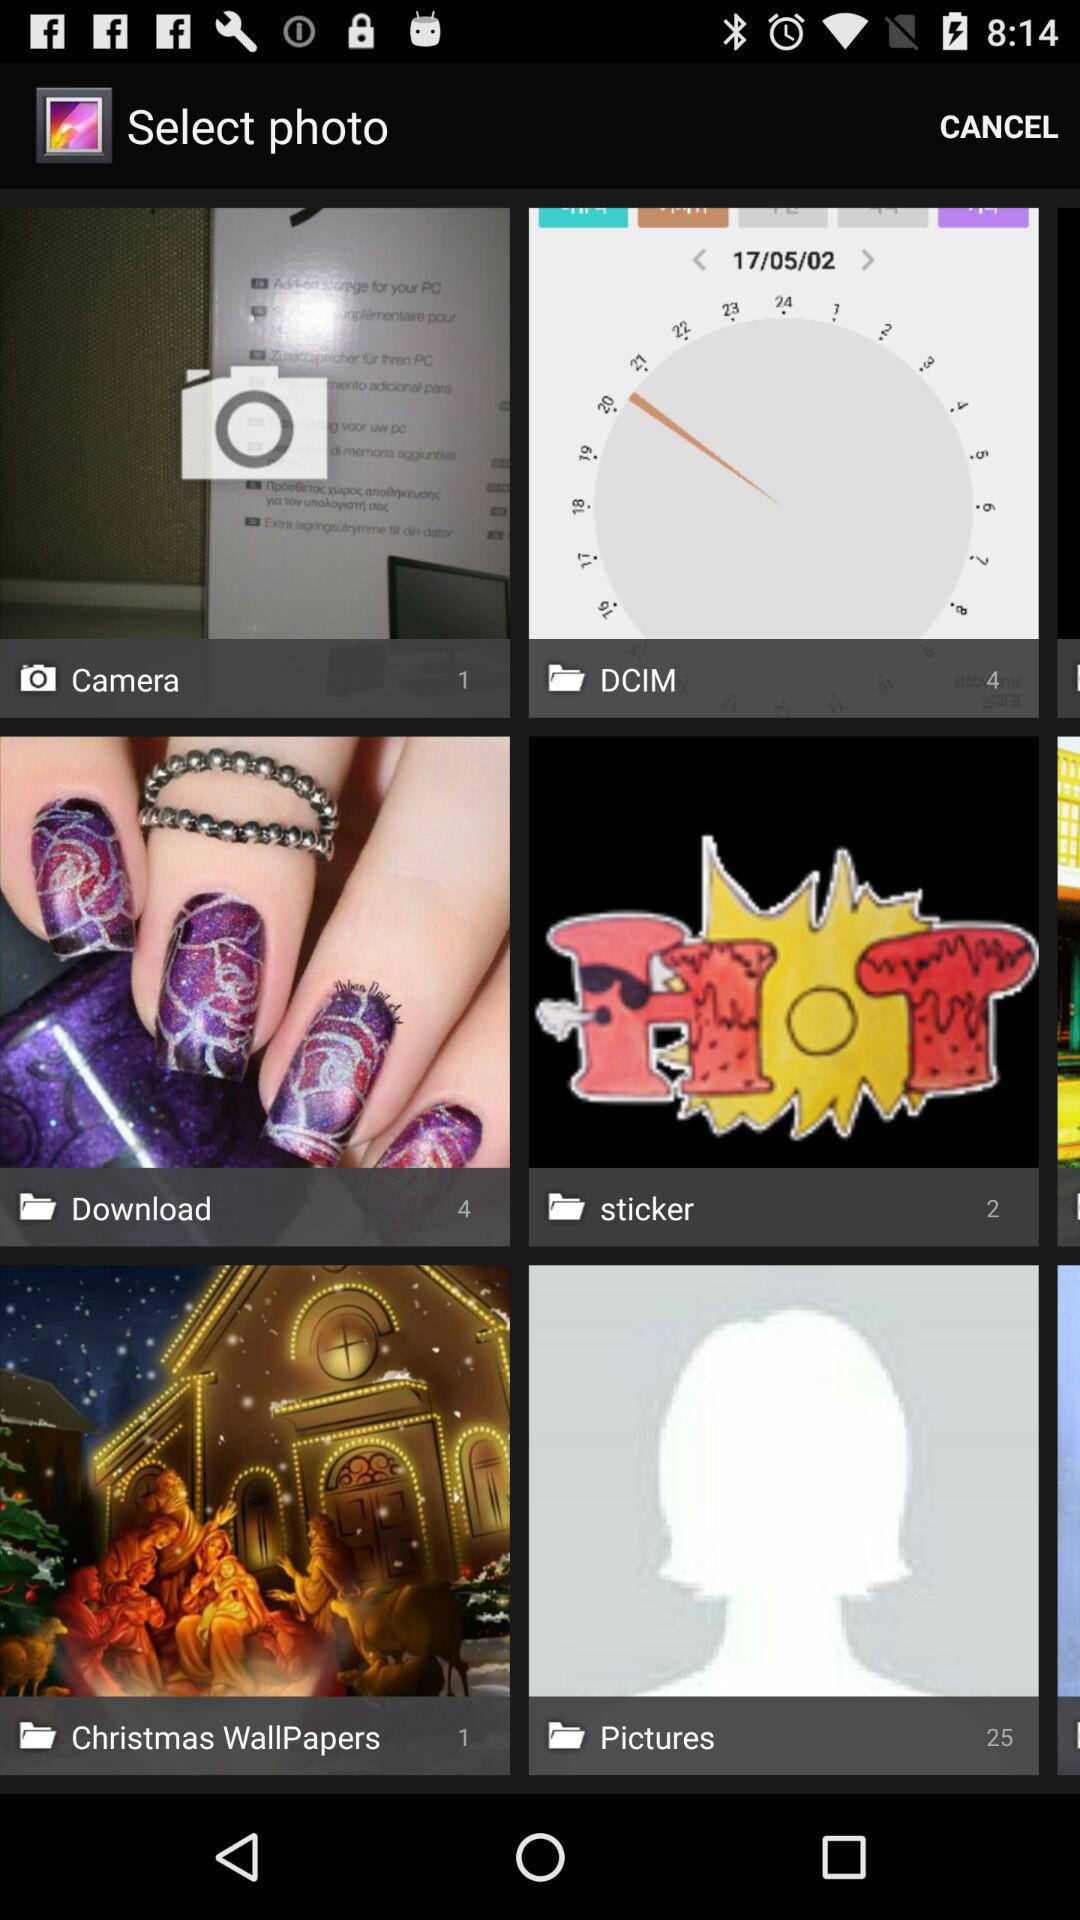How many pictures are there in "Download"? There are 4 pictures in "Download". 